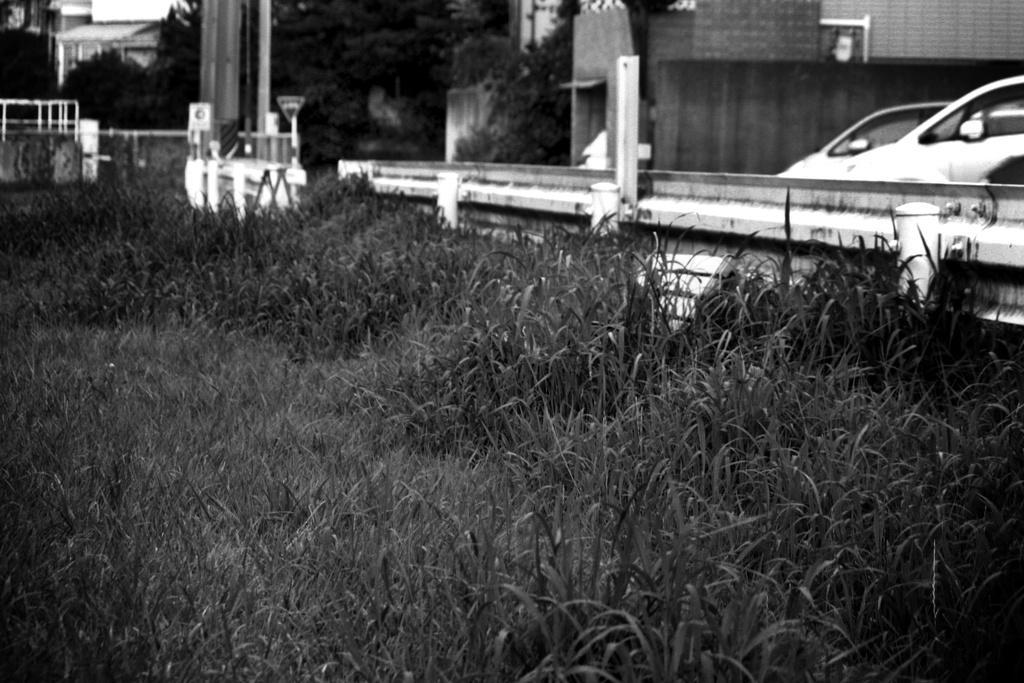Can you describe this image briefly? Here we can see grass and cars. On the background we can see wall,trees and sky. 